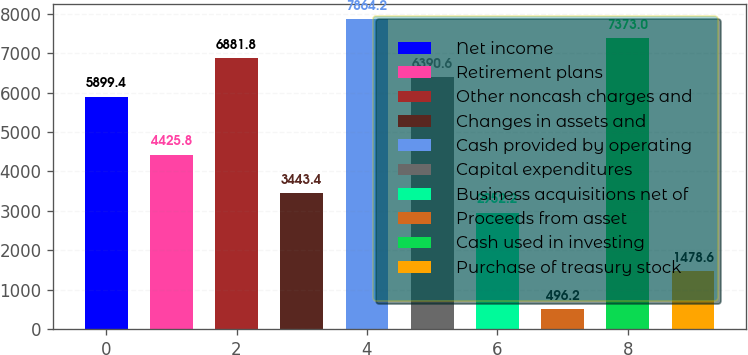Convert chart. <chart><loc_0><loc_0><loc_500><loc_500><bar_chart><fcel>Net income<fcel>Retirement plans<fcel>Other noncash charges and<fcel>Changes in assets and<fcel>Cash provided by operating<fcel>Capital expenditures<fcel>Business acquisitions net of<fcel>Proceeds from asset<fcel>Cash used in investing<fcel>Purchase of treasury stock<nl><fcel>5899.4<fcel>4425.8<fcel>6881.8<fcel>3443.4<fcel>7864.2<fcel>6390.6<fcel>2952.2<fcel>496.2<fcel>7373<fcel>1478.6<nl></chart> 